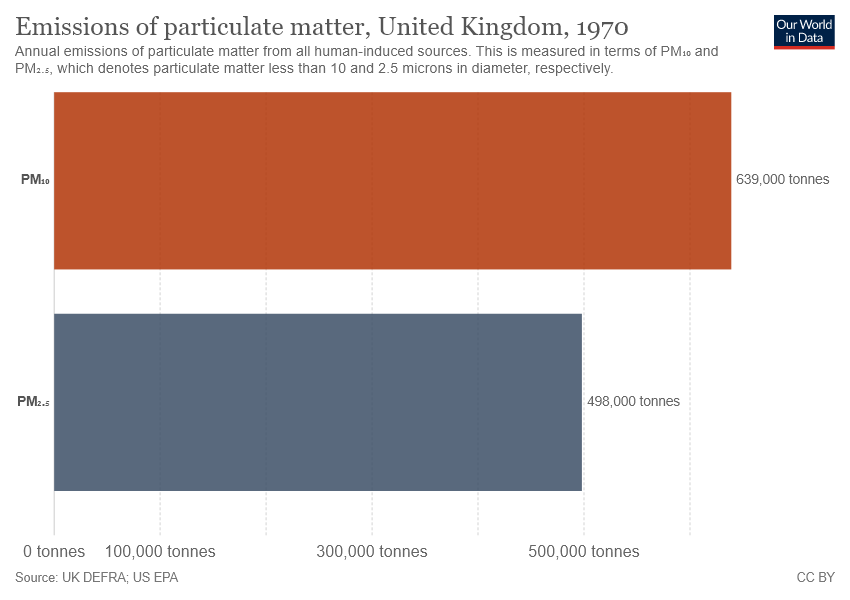Indicate a few pertinent items in this graphic. The uppermost bar in the graph has a value of 639,000. 